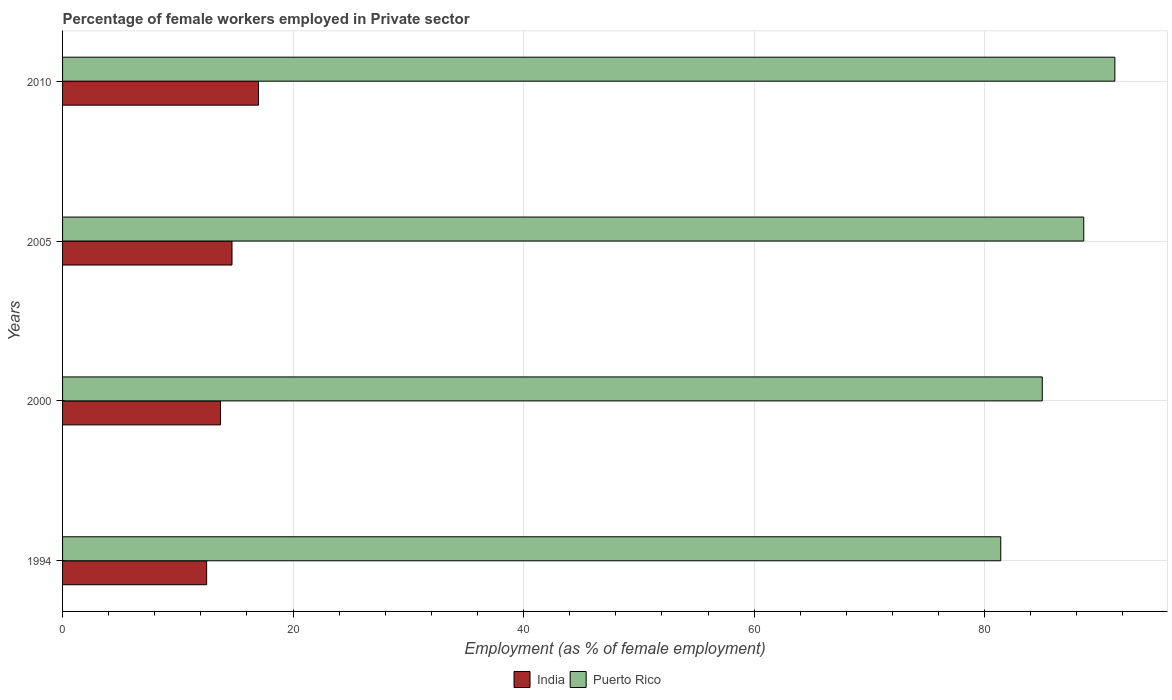How many groups of bars are there?
Keep it short and to the point. 4. Are the number of bars on each tick of the Y-axis equal?
Your response must be concise. Yes. How many bars are there on the 2nd tick from the top?
Give a very brief answer. 2. Across all years, what is the maximum percentage of females employed in Private sector in Puerto Rico?
Provide a succinct answer. 91.3. Across all years, what is the minimum percentage of females employed in Private sector in Puerto Rico?
Your answer should be very brief. 81.4. What is the total percentage of females employed in Private sector in India in the graph?
Make the answer very short. 57.9. What is the difference between the percentage of females employed in Private sector in India in 2005 and that in 2010?
Offer a terse response. -2.3. What is the difference between the percentage of females employed in Private sector in Puerto Rico in 1994 and the percentage of females employed in Private sector in India in 2000?
Provide a short and direct response. 67.7. What is the average percentage of females employed in Private sector in India per year?
Your answer should be very brief. 14.47. In the year 1994, what is the difference between the percentage of females employed in Private sector in India and percentage of females employed in Private sector in Puerto Rico?
Make the answer very short. -68.9. What is the ratio of the percentage of females employed in Private sector in Puerto Rico in 1994 to that in 2005?
Your answer should be very brief. 0.92. Is the percentage of females employed in Private sector in India in 1994 less than that in 2005?
Your answer should be compact. Yes. Is the difference between the percentage of females employed in Private sector in India in 2000 and 2010 greater than the difference between the percentage of females employed in Private sector in Puerto Rico in 2000 and 2010?
Your answer should be compact. Yes. What is the difference between the highest and the second highest percentage of females employed in Private sector in Puerto Rico?
Your answer should be very brief. 2.7. What is the difference between the highest and the lowest percentage of females employed in Private sector in Puerto Rico?
Offer a very short reply. 9.9. Is the sum of the percentage of females employed in Private sector in India in 1994 and 2005 greater than the maximum percentage of females employed in Private sector in Puerto Rico across all years?
Offer a terse response. No. What does the 1st bar from the top in 2000 represents?
Provide a short and direct response. Puerto Rico. Are all the bars in the graph horizontal?
Provide a short and direct response. Yes. Does the graph contain any zero values?
Provide a short and direct response. No. Does the graph contain grids?
Provide a succinct answer. Yes. Where does the legend appear in the graph?
Your response must be concise. Bottom center. What is the title of the graph?
Provide a succinct answer. Percentage of female workers employed in Private sector. What is the label or title of the X-axis?
Your answer should be compact. Employment (as % of female employment). What is the label or title of the Y-axis?
Your answer should be compact. Years. What is the Employment (as % of female employment) of India in 1994?
Your answer should be compact. 12.5. What is the Employment (as % of female employment) in Puerto Rico in 1994?
Provide a short and direct response. 81.4. What is the Employment (as % of female employment) of India in 2000?
Your answer should be very brief. 13.7. What is the Employment (as % of female employment) in India in 2005?
Offer a terse response. 14.7. What is the Employment (as % of female employment) in Puerto Rico in 2005?
Offer a very short reply. 88.6. What is the Employment (as % of female employment) of Puerto Rico in 2010?
Make the answer very short. 91.3. Across all years, what is the maximum Employment (as % of female employment) of India?
Make the answer very short. 17. Across all years, what is the maximum Employment (as % of female employment) in Puerto Rico?
Your answer should be very brief. 91.3. Across all years, what is the minimum Employment (as % of female employment) in Puerto Rico?
Your response must be concise. 81.4. What is the total Employment (as % of female employment) of India in the graph?
Provide a succinct answer. 57.9. What is the total Employment (as % of female employment) of Puerto Rico in the graph?
Your answer should be compact. 346.3. What is the difference between the Employment (as % of female employment) in India in 1994 and that in 2000?
Keep it short and to the point. -1.2. What is the difference between the Employment (as % of female employment) in India in 1994 and that in 2005?
Offer a very short reply. -2.2. What is the difference between the Employment (as % of female employment) in India in 1994 and that in 2010?
Give a very brief answer. -4.5. What is the difference between the Employment (as % of female employment) of Puerto Rico in 1994 and that in 2010?
Give a very brief answer. -9.9. What is the difference between the Employment (as % of female employment) of Puerto Rico in 2000 and that in 2005?
Provide a short and direct response. -3.6. What is the difference between the Employment (as % of female employment) of India in 1994 and the Employment (as % of female employment) of Puerto Rico in 2000?
Your response must be concise. -72.5. What is the difference between the Employment (as % of female employment) in India in 1994 and the Employment (as % of female employment) in Puerto Rico in 2005?
Your answer should be compact. -76.1. What is the difference between the Employment (as % of female employment) of India in 1994 and the Employment (as % of female employment) of Puerto Rico in 2010?
Ensure brevity in your answer.  -78.8. What is the difference between the Employment (as % of female employment) of India in 2000 and the Employment (as % of female employment) of Puerto Rico in 2005?
Your response must be concise. -74.9. What is the difference between the Employment (as % of female employment) of India in 2000 and the Employment (as % of female employment) of Puerto Rico in 2010?
Make the answer very short. -77.6. What is the difference between the Employment (as % of female employment) of India in 2005 and the Employment (as % of female employment) of Puerto Rico in 2010?
Keep it short and to the point. -76.6. What is the average Employment (as % of female employment) in India per year?
Offer a terse response. 14.47. What is the average Employment (as % of female employment) of Puerto Rico per year?
Your response must be concise. 86.58. In the year 1994, what is the difference between the Employment (as % of female employment) in India and Employment (as % of female employment) in Puerto Rico?
Your response must be concise. -68.9. In the year 2000, what is the difference between the Employment (as % of female employment) in India and Employment (as % of female employment) in Puerto Rico?
Keep it short and to the point. -71.3. In the year 2005, what is the difference between the Employment (as % of female employment) of India and Employment (as % of female employment) of Puerto Rico?
Offer a very short reply. -73.9. In the year 2010, what is the difference between the Employment (as % of female employment) of India and Employment (as % of female employment) of Puerto Rico?
Your answer should be very brief. -74.3. What is the ratio of the Employment (as % of female employment) in India in 1994 to that in 2000?
Your answer should be very brief. 0.91. What is the ratio of the Employment (as % of female employment) of Puerto Rico in 1994 to that in 2000?
Your response must be concise. 0.96. What is the ratio of the Employment (as % of female employment) of India in 1994 to that in 2005?
Provide a succinct answer. 0.85. What is the ratio of the Employment (as % of female employment) in Puerto Rico in 1994 to that in 2005?
Provide a short and direct response. 0.92. What is the ratio of the Employment (as % of female employment) in India in 1994 to that in 2010?
Your answer should be compact. 0.74. What is the ratio of the Employment (as % of female employment) in Puerto Rico in 1994 to that in 2010?
Keep it short and to the point. 0.89. What is the ratio of the Employment (as % of female employment) of India in 2000 to that in 2005?
Make the answer very short. 0.93. What is the ratio of the Employment (as % of female employment) of Puerto Rico in 2000 to that in 2005?
Give a very brief answer. 0.96. What is the ratio of the Employment (as % of female employment) of India in 2000 to that in 2010?
Offer a terse response. 0.81. What is the ratio of the Employment (as % of female employment) in India in 2005 to that in 2010?
Offer a terse response. 0.86. What is the ratio of the Employment (as % of female employment) in Puerto Rico in 2005 to that in 2010?
Ensure brevity in your answer.  0.97. What is the difference between the highest and the second highest Employment (as % of female employment) of India?
Ensure brevity in your answer.  2.3. What is the difference between the highest and the second highest Employment (as % of female employment) of Puerto Rico?
Your response must be concise. 2.7. 